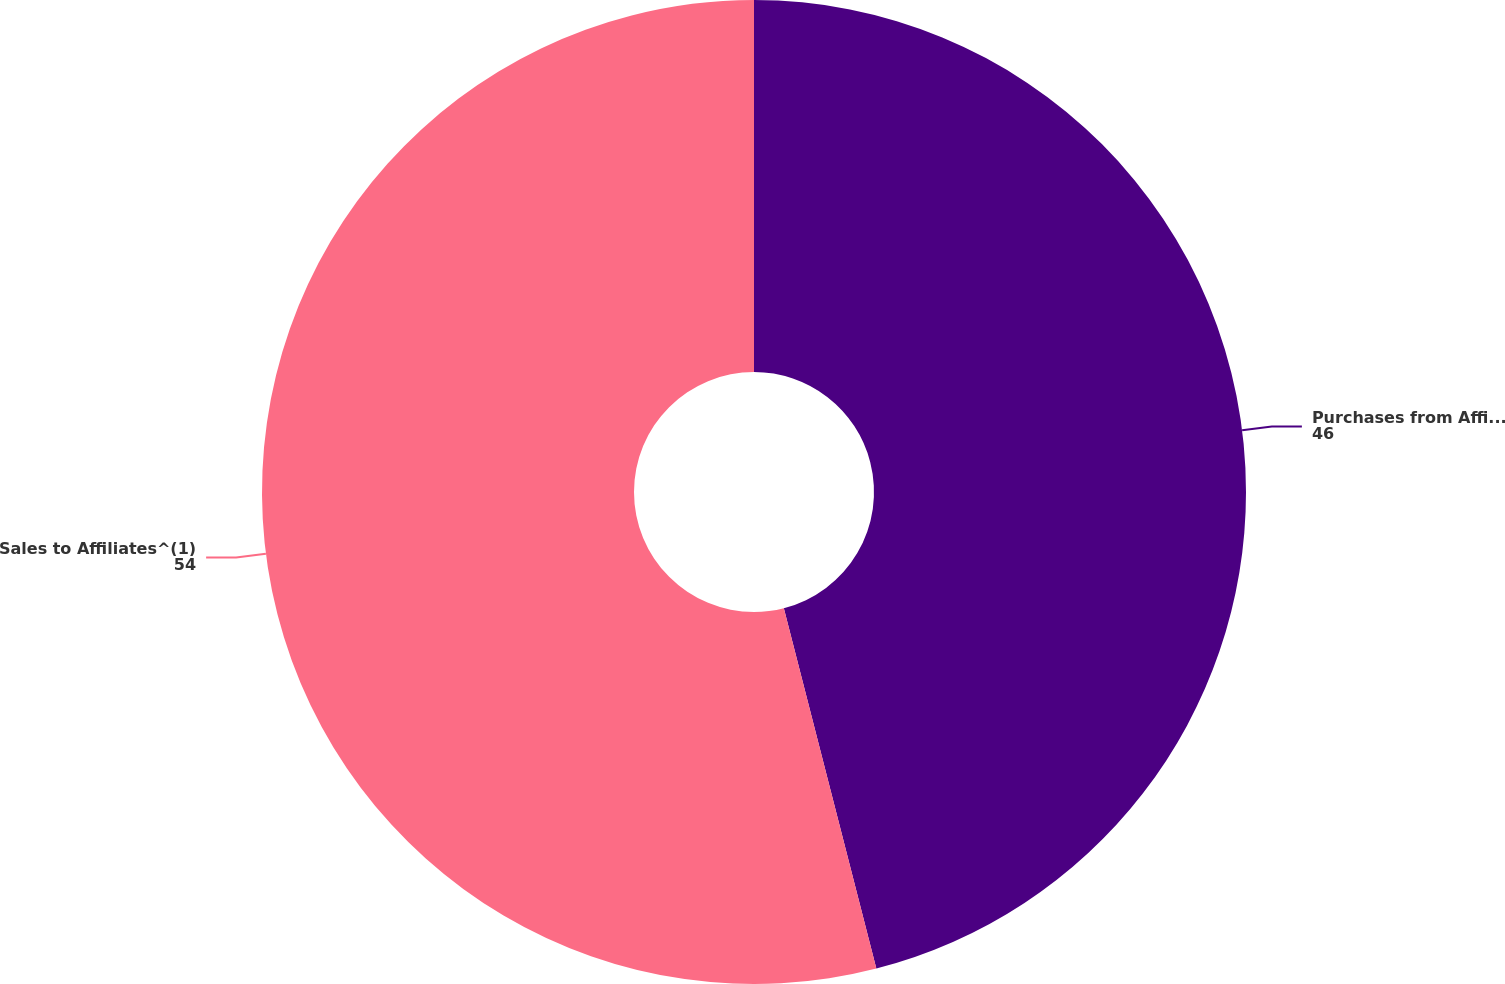Convert chart. <chart><loc_0><loc_0><loc_500><loc_500><pie_chart><fcel>Purchases from Affiliates (1)<fcel>Sales to Affiliates^(1)<nl><fcel>46.0%<fcel>54.0%<nl></chart> 